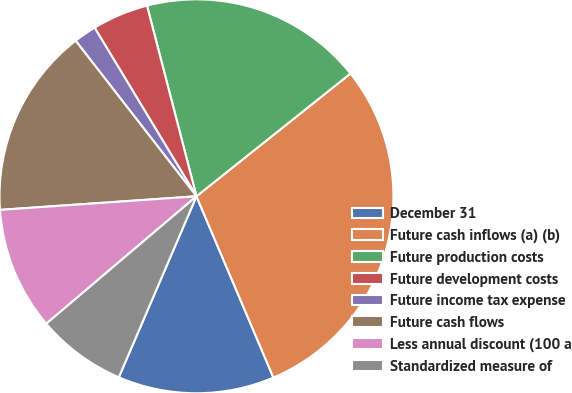<chart> <loc_0><loc_0><loc_500><loc_500><pie_chart><fcel>December 31<fcel>Future cash inflows (a) (b)<fcel>Future production costs<fcel>Future development costs<fcel>Future income tax expense<fcel>Future cash flows<fcel>Less annual discount (100 a<fcel>Standardized measure of<nl><fcel>12.84%<fcel>29.32%<fcel>18.33%<fcel>4.61%<fcel>1.86%<fcel>15.59%<fcel>10.1%<fcel>7.35%<nl></chart> 